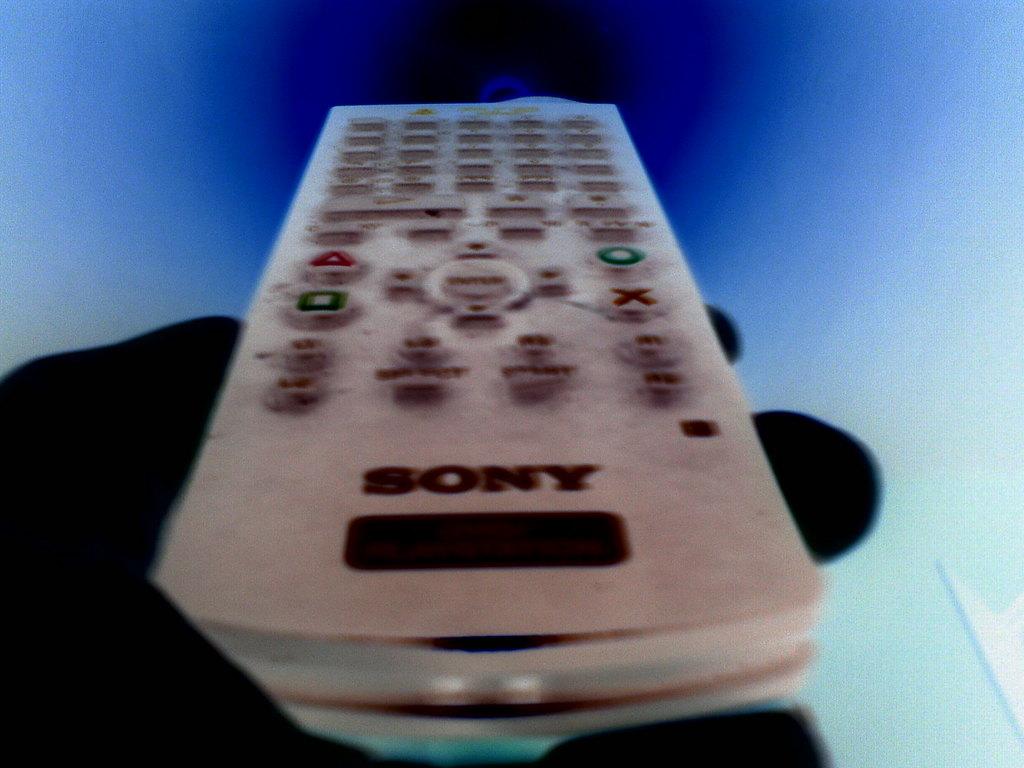What brand is the remote?
Offer a very short reply. Sony. 